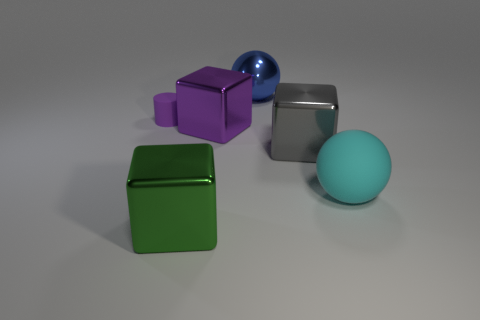There is a metallic object that is the same color as the tiny cylinder; what size is it?
Your response must be concise. Large. There is a rubber thing that is the same size as the purple metal block; what is its color?
Provide a succinct answer. Cyan. What material is the block that is on the right side of the large sphere left of the large sphere right of the big blue thing?
Your response must be concise. Metal. Do the matte ball and the big metal block that is on the right side of the big metallic ball have the same color?
Your response must be concise. No. How many objects are big things that are behind the cylinder or rubber things that are on the right side of the small purple rubber object?
Your answer should be compact. 2. What is the shape of the matte thing that is on the left side of the big metal thing that is in front of the large cyan thing?
Make the answer very short. Cylinder. Are there any cylinders that have the same material as the cyan object?
Offer a terse response. Yes. What is the color of the other large object that is the same shape as the large cyan thing?
Your answer should be very brief. Blue. Are there fewer small purple matte objects that are right of the purple rubber cylinder than large gray metallic objects to the right of the cyan thing?
Your answer should be very brief. No. What number of other things are the same shape as the cyan matte thing?
Make the answer very short. 1. 